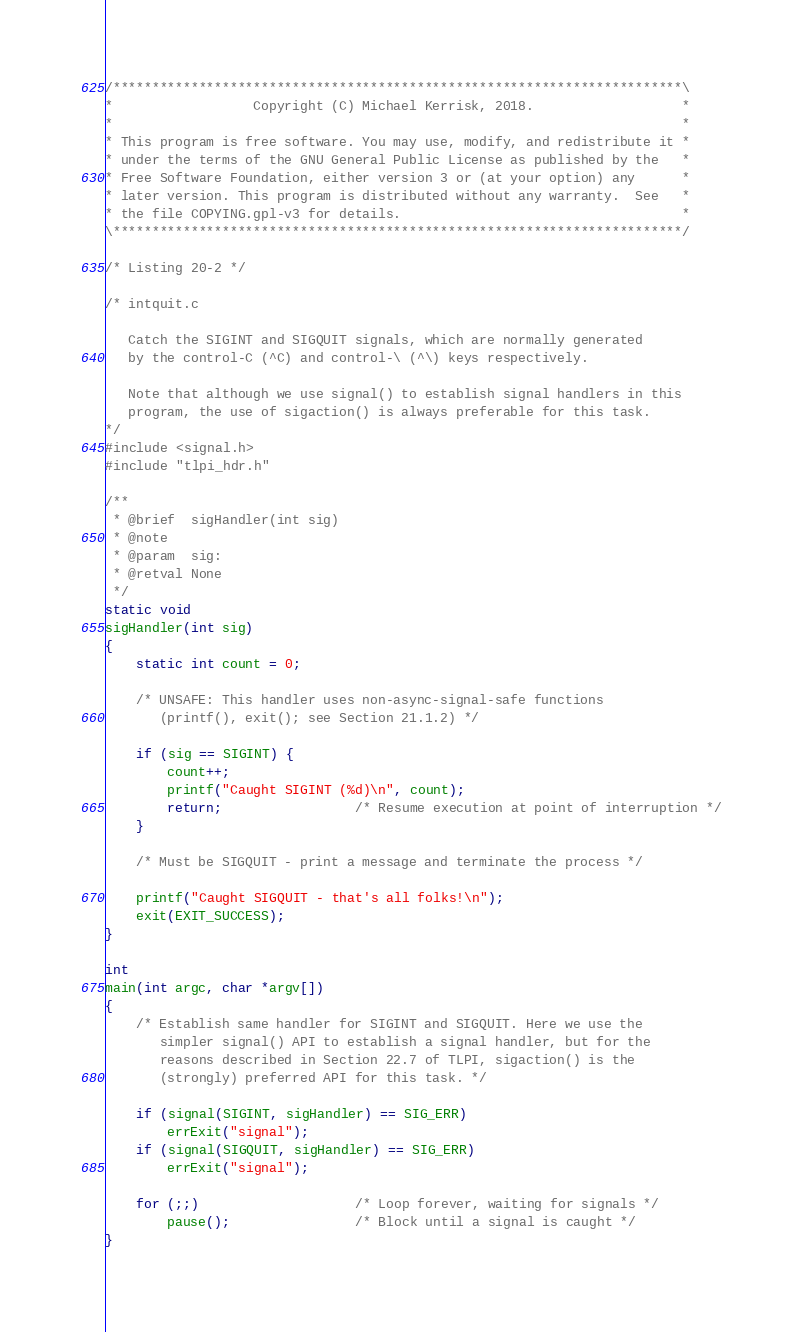Convert code to text. <code><loc_0><loc_0><loc_500><loc_500><_C_>/*************************************************************************\
*                  Copyright (C) Michael Kerrisk, 2018.                   *
*                                                                         *
* This program is free software. You may use, modify, and redistribute it *
* under the terms of the GNU General Public License as published by the   *
* Free Software Foundation, either version 3 or (at your option) any      *
* later version. This program is distributed without any warranty.  See   *
* the file COPYING.gpl-v3 for details.                                    *
\*************************************************************************/

/* Listing 20-2 */

/* intquit.c

   Catch the SIGINT and SIGQUIT signals, which are normally generated
   by the control-C (^C) and control-\ (^\) keys respectively.

   Note that although we use signal() to establish signal handlers in this
   program, the use of sigaction() is always preferable for this task.
*/
#include <signal.h>
#include "tlpi_hdr.h"

/**
 * @brief  sigHandler(int sig)
 * @note   
 * @param  sig: 
 * @retval None
 */
static void
sigHandler(int sig)
{
    static int count = 0;

    /* UNSAFE: This handler uses non-async-signal-safe functions
       (printf(), exit(); see Section 21.1.2) */

    if (sig == SIGINT) {
        count++;
        printf("Caught SIGINT (%d)\n", count);
        return;                 /* Resume execution at point of interruption */
    }

    /* Must be SIGQUIT - print a message and terminate the process */

    printf("Caught SIGQUIT - that's all folks!\n");
    exit(EXIT_SUCCESS);
}

int
main(int argc, char *argv[])
{
    /* Establish same handler for SIGINT and SIGQUIT. Here we use the
       simpler signal() API to establish a signal handler, but for the
       reasons described in Section 22.7 of TLPI, sigaction() is the
       (strongly) preferred API for this task. */

    if (signal(SIGINT, sigHandler) == SIG_ERR)
        errExit("signal");
    if (signal(SIGQUIT, sigHandler) == SIG_ERR)
        errExit("signal");

    for (;;)                    /* Loop forever, waiting for signals */
        pause();                /* Block until a signal is caught */
}
</code> 